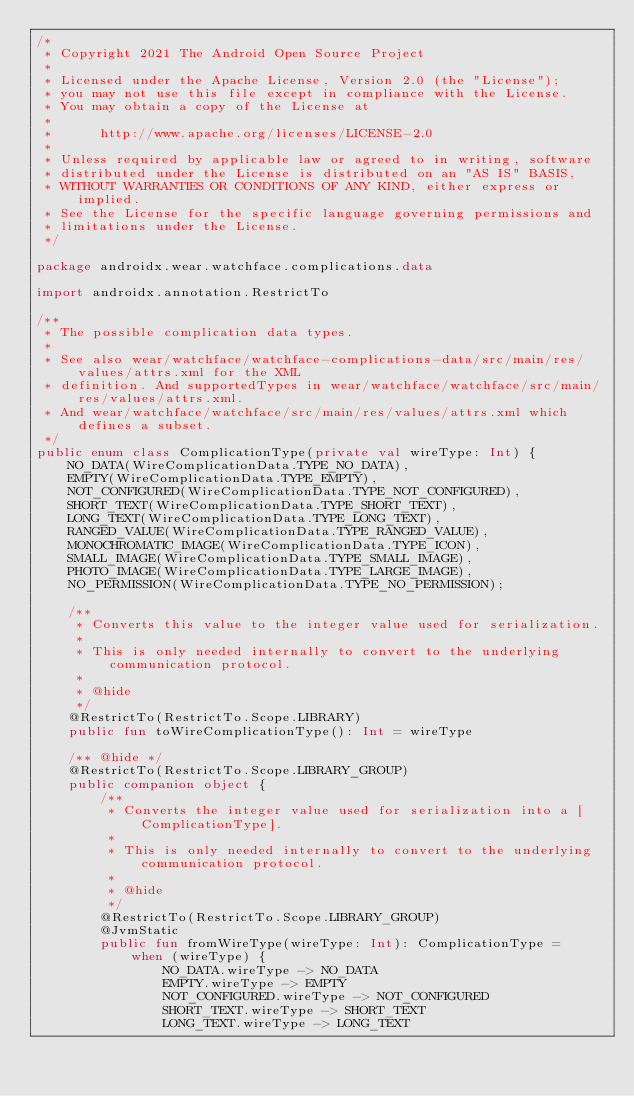<code> <loc_0><loc_0><loc_500><loc_500><_Kotlin_>/*
 * Copyright 2021 The Android Open Source Project
 *
 * Licensed under the Apache License, Version 2.0 (the "License");
 * you may not use this file except in compliance with the License.
 * You may obtain a copy of the License at
 *
 *      http://www.apache.org/licenses/LICENSE-2.0
 *
 * Unless required by applicable law or agreed to in writing, software
 * distributed under the License is distributed on an "AS IS" BASIS,
 * WITHOUT WARRANTIES OR CONDITIONS OF ANY KIND, either express or implied.
 * See the License for the specific language governing permissions and
 * limitations under the License.
 */

package androidx.wear.watchface.complications.data

import androidx.annotation.RestrictTo

/**
 * The possible complication data types.
 *
 * See also wear/watchface/watchface-complications-data/src/main/res/values/attrs.xml for the XML
 * definition. And supportedTypes in wear/watchface/watchface/src/main/res/values/attrs.xml.
 * And wear/watchface/watchface/src/main/res/values/attrs.xml which defines a subset.
 */
public enum class ComplicationType(private val wireType: Int) {
    NO_DATA(WireComplicationData.TYPE_NO_DATA),
    EMPTY(WireComplicationData.TYPE_EMPTY),
    NOT_CONFIGURED(WireComplicationData.TYPE_NOT_CONFIGURED),
    SHORT_TEXT(WireComplicationData.TYPE_SHORT_TEXT),
    LONG_TEXT(WireComplicationData.TYPE_LONG_TEXT),
    RANGED_VALUE(WireComplicationData.TYPE_RANGED_VALUE),
    MONOCHROMATIC_IMAGE(WireComplicationData.TYPE_ICON),
    SMALL_IMAGE(WireComplicationData.TYPE_SMALL_IMAGE),
    PHOTO_IMAGE(WireComplicationData.TYPE_LARGE_IMAGE),
    NO_PERMISSION(WireComplicationData.TYPE_NO_PERMISSION);

    /**
     * Converts this value to the integer value used for serialization.
     *
     * This is only needed internally to convert to the underlying communication protocol.
     *
     * @hide
     */
    @RestrictTo(RestrictTo.Scope.LIBRARY)
    public fun toWireComplicationType(): Int = wireType

    /** @hide */
    @RestrictTo(RestrictTo.Scope.LIBRARY_GROUP)
    public companion object {
        /**
         * Converts the integer value used for serialization into a [ComplicationType].
         *
         * This is only needed internally to convert to the underlying communication protocol.
         *
         * @hide
         */
        @RestrictTo(RestrictTo.Scope.LIBRARY_GROUP)
        @JvmStatic
        public fun fromWireType(wireType: Int): ComplicationType =
            when (wireType) {
                NO_DATA.wireType -> NO_DATA
                EMPTY.wireType -> EMPTY
                NOT_CONFIGURED.wireType -> NOT_CONFIGURED
                SHORT_TEXT.wireType -> SHORT_TEXT
                LONG_TEXT.wireType -> LONG_TEXT</code> 